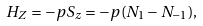Convert formula to latex. <formula><loc_0><loc_0><loc_500><loc_500>H _ { Z } = - p S _ { z } = - p ( N _ { 1 } - N _ { - 1 } ) ,</formula> 